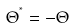Convert formula to latex. <formula><loc_0><loc_0><loc_500><loc_500>\Theta ^ { ^ { * } } = - \Theta</formula> 